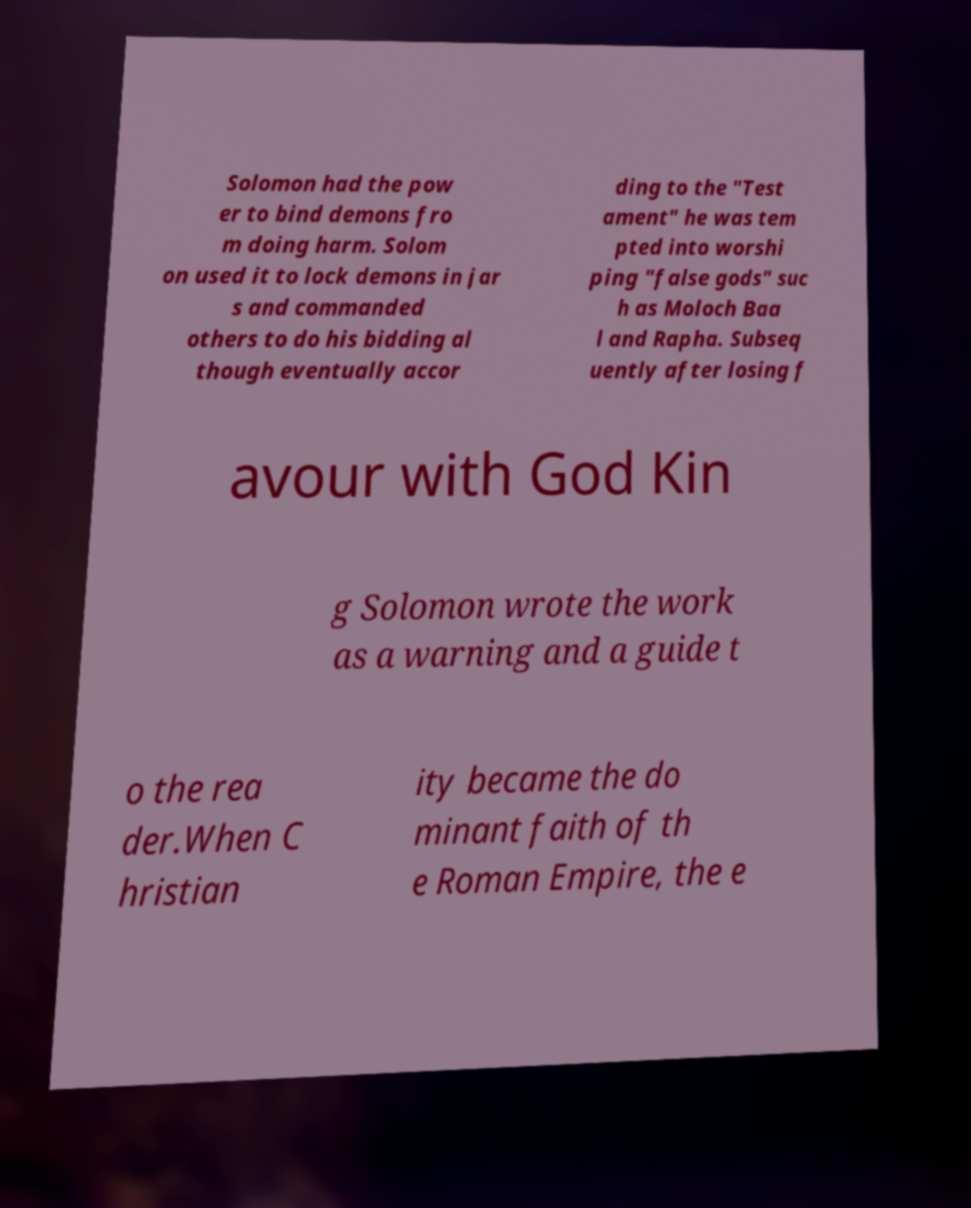Please read and relay the text visible in this image. What does it say? Solomon had the pow er to bind demons fro m doing harm. Solom on used it to lock demons in jar s and commanded others to do his bidding al though eventually accor ding to the "Test ament" he was tem pted into worshi ping "false gods" suc h as Moloch Baa l and Rapha. Subseq uently after losing f avour with God Kin g Solomon wrote the work as a warning and a guide t o the rea der.When C hristian ity became the do minant faith of th e Roman Empire, the e 